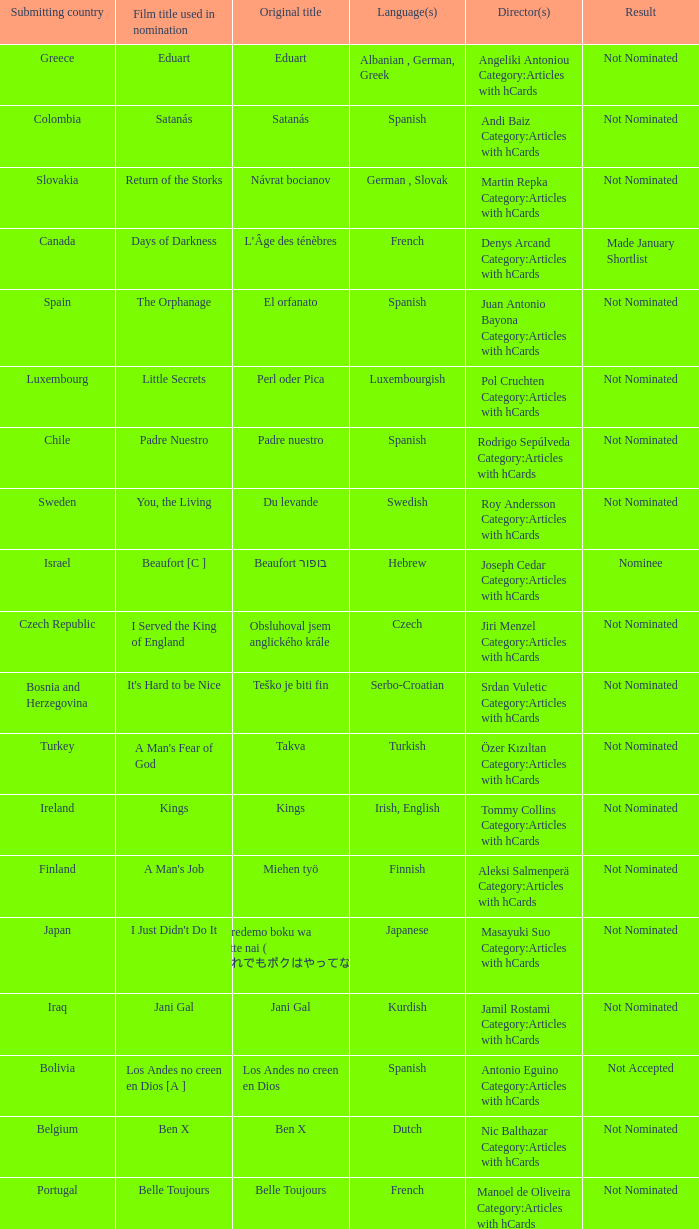What country submitted miehen työ? Finland. 